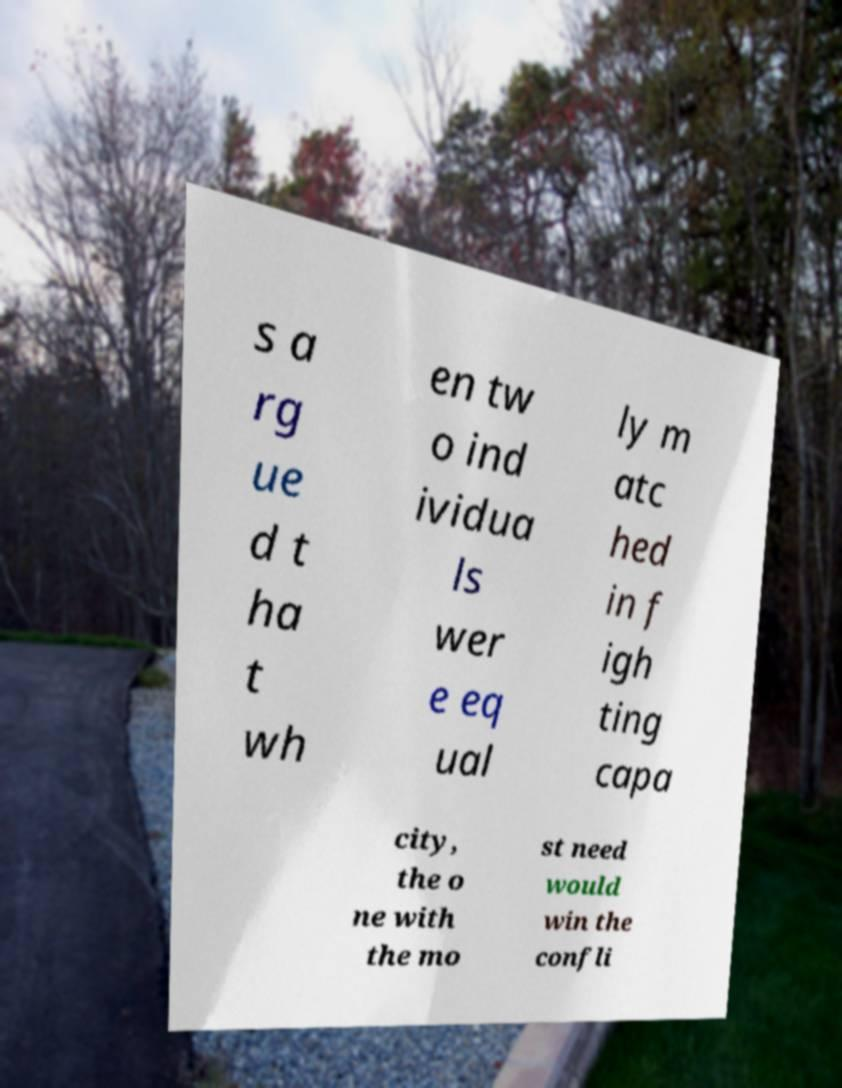For documentation purposes, I need the text within this image transcribed. Could you provide that? s a rg ue d t ha t wh en tw o ind ividua ls wer e eq ual ly m atc hed in f igh ting capa city, the o ne with the mo st need would win the confli 